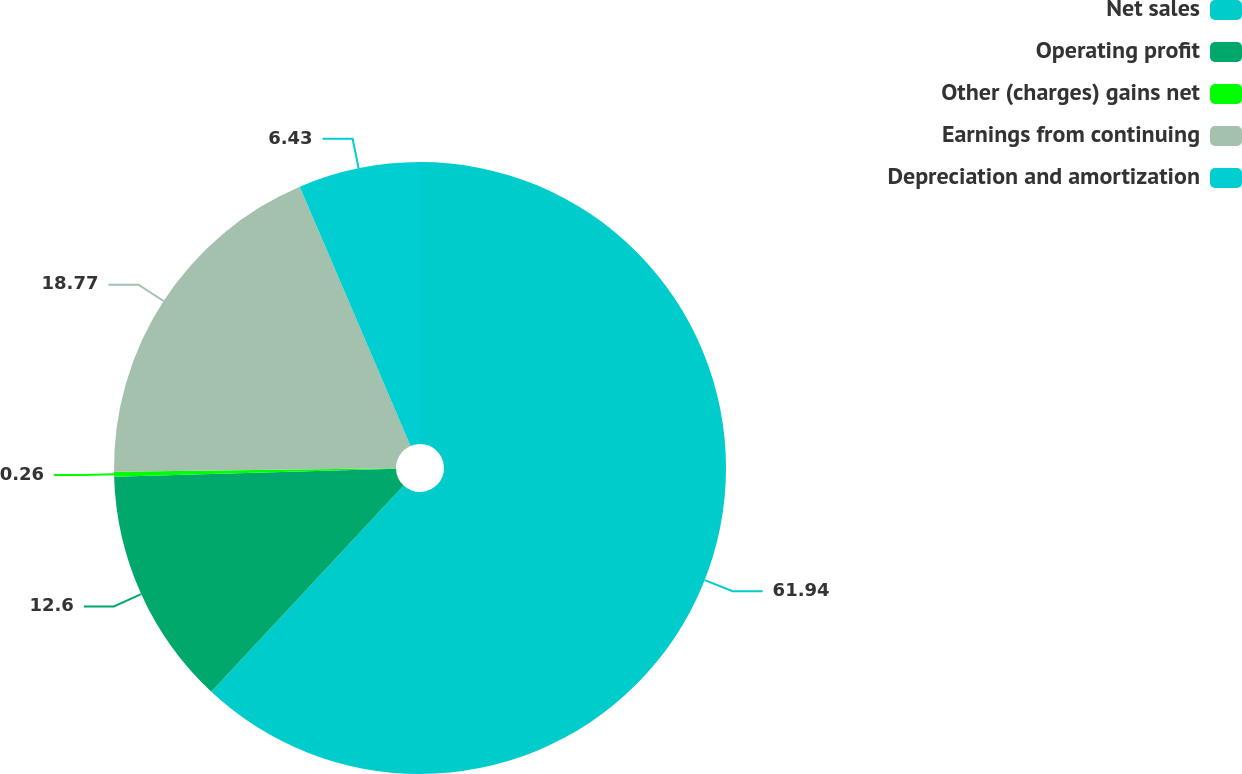<chart> <loc_0><loc_0><loc_500><loc_500><pie_chart><fcel>Net sales<fcel>Operating profit<fcel>Other (charges) gains net<fcel>Earnings from continuing<fcel>Depreciation and amortization<nl><fcel>61.95%<fcel>12.6%<fcel>0.26%<fcel>18.77%<fcel>6.43%<nl></chart> 